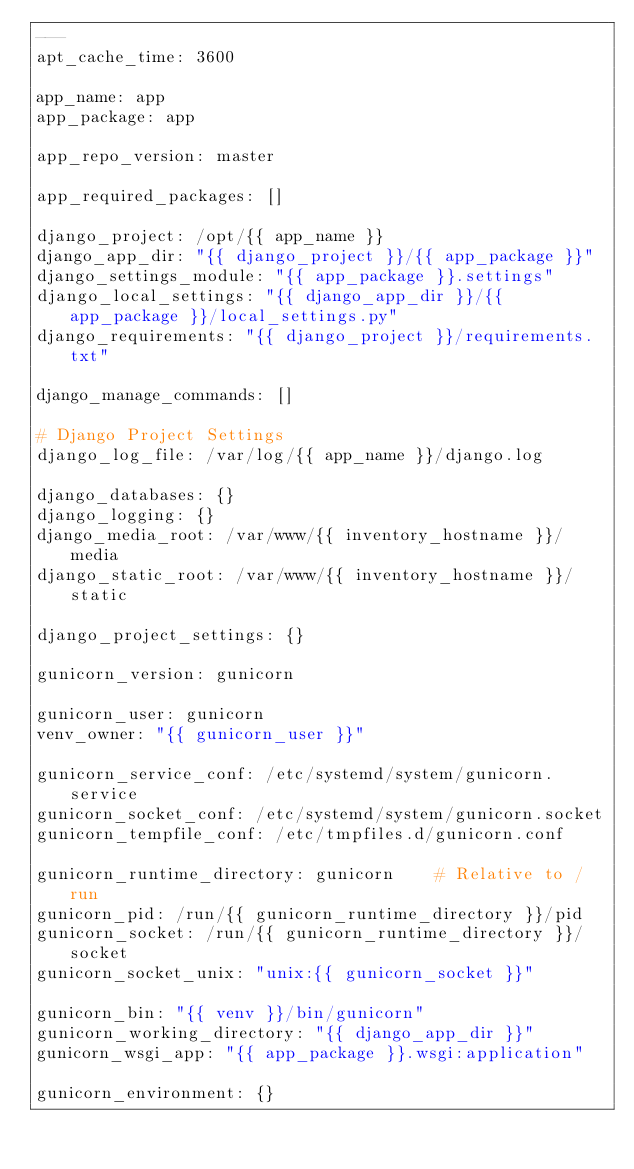<code> <loc_0><loc_0><loc_500><loc_500><_YAML_>---
apt_cache_time: 3600

app_name: app
app_package: app

app_repo_version: master

app_required_packages: []

django_project: /opt/{{ app_name }}
django_app_dir: "{{ django_project }}/{{ app_package }}"
django_settings_module: "{{ app_package }}.settings"
django_local_settings: "{{ django_app_dir }}/{{ app_package }}/local_settings.py"
django_requirements: "{{ django_project }}/requirements.txt"

django_manage_commands: []

# Django Project Settings
django_log_file: /var/log/{{ app_name }}/django.log

django_databases: {}
django_logging: {}
django_media_root: /var/www/{{ inventory_hostname }}/media
django_static_root: /var/www/{{ inventory_hostname }}/static

django_project_settings: {}

gunicorn_version: gunicorn

gunicorn_user: gunicorn
venv_owner: "{{ gunicorn_user }}"

gunicorn_service_conf: /etc/systemd/system/gunicorn.service
gunicorn_socket_conf: /etc/systemd/system/gunicorn.socket
gunicorn_tempfile_conf: /etc/tmpfiles.d/gunicorn.conf

gunicorn_runtime_directory: gunicorn    # Relative to /run
gunicorn_pid: /run/{{ gunicorn_runtime_directory }}/pid
gunicorn_socket: /run/{{ gunicorn_runtime_directory }}/socket
gunicorn_socket_unix: "unix:{{ gunicorn_socket }}"

gunicorn_bin: "{{ venv }}/bin/gunicorn"
gunicorn_working_directory: "{{ django_app_dir }}"
gunicorn_wsgi_app: "{{ app_package }}.wsgi:application"

gunicorn_environment: {}
</code> 